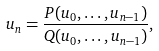Convert formula to latex. <formula><loc_0><loc_0><loc_500><loc_500>u _ { n } = \frac { P ( u _ { 0 } , \dots , u _ { n - 1 } ) } { Q ( u _ { 0 } , \dots , u _ { n - 1 } ) } ,</formula> 